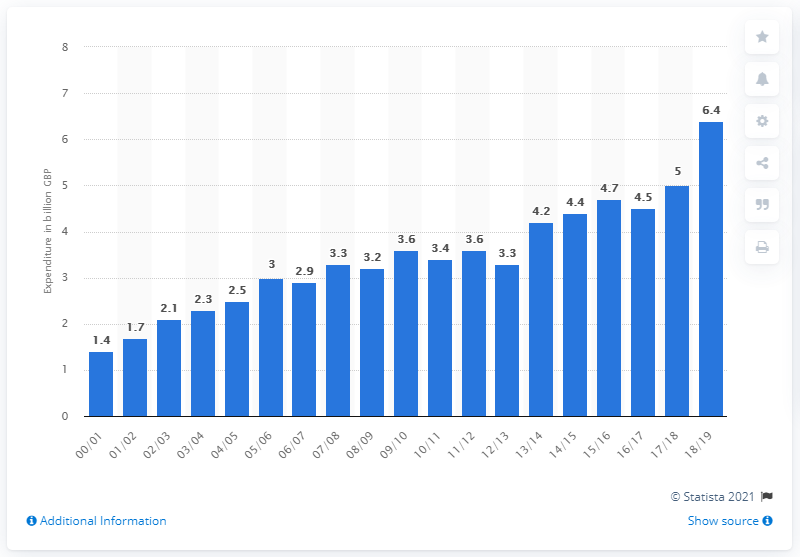Indicate a few pertinent items in this graphic. In the 2018/19 fiscal year, the peak amount of public spending on science and technology was 6.4%. 